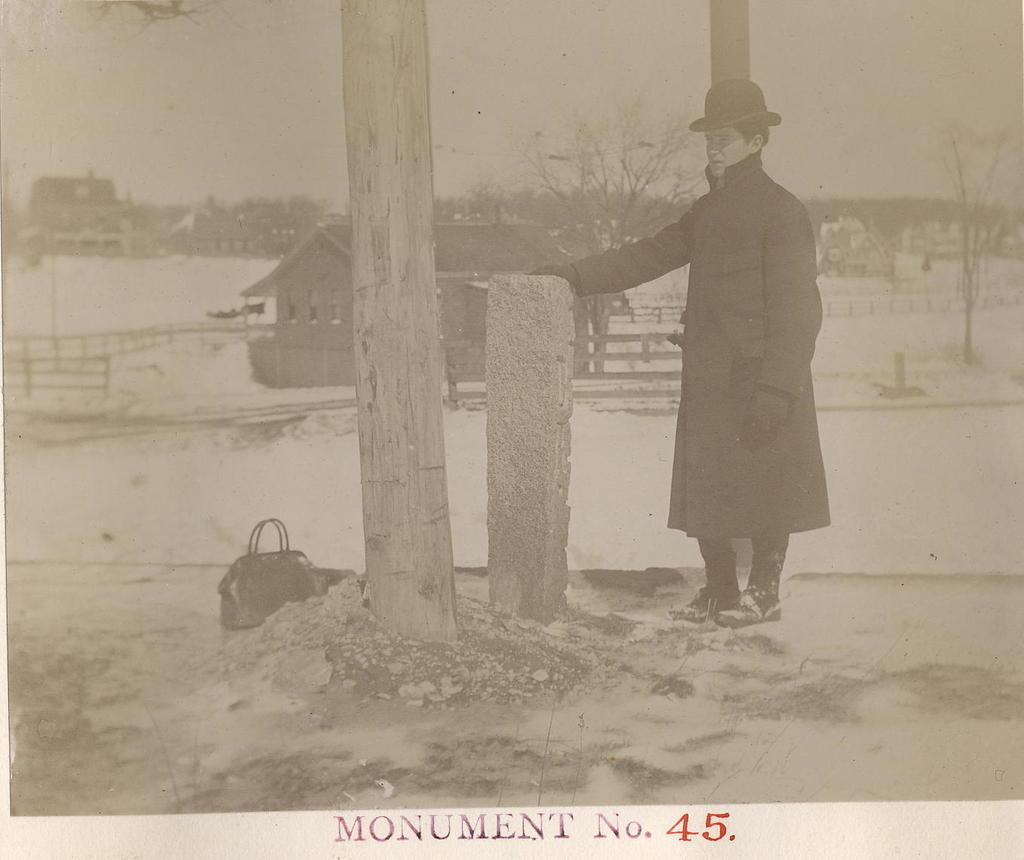What can be seen in the image? There is a person in the image. Can you describe the person's attire? The person is wearing a hat. What is visible in the background of the image? There is a house and trees in the background of the image. What other notable feature is present in the image? The image contains a monument with the number 45. What type of straw is the person holding in the image? There is no straw present in the image. What scientific theory can be observed in the image? There is no scientific theory depicted in the image. 